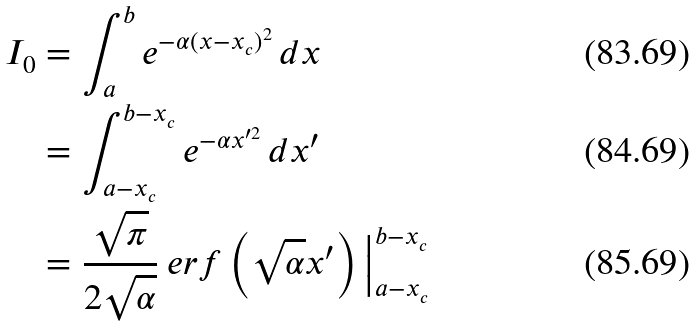<formula> <loc_0><loc_0><loc_500><loc_500>I _ { 0 } & = \int _ { a } ^ { b } e ^ { - \alpha ( x - x _ { c } ) ^ { 2 } } \, d x \\ & = \int _ { a - x _ { c } } ^ { b - x _ { c } } e ^ { - \alpha x ^ { \prime 2 } } \, d x ^ { \prime } \\ & = \frac { \sqrt { \pi } } { 2 \sqrt { \alpha } } \ e r f \left ( \sqrt { \alpha } x ^ { \prime } \right ) \Big | _ { a - x _ { c } } ^ { b - x _ { c } }</formula> 